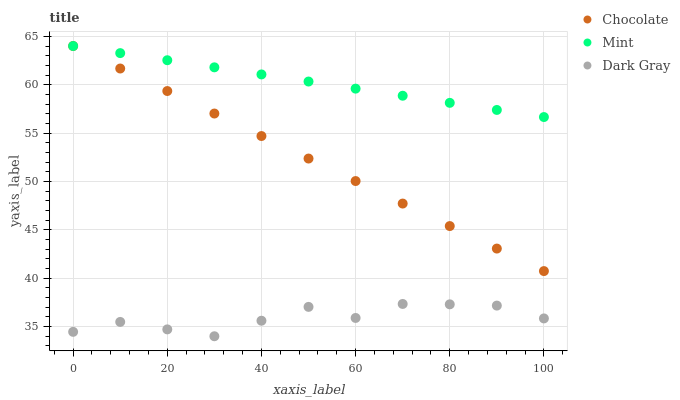Does Dark Gray have the minimum area under the curve?
Answer yes or no. Yes. Does Mint have the maximum area under the curve?
Answer yes or no. Yes. Does Chocolate have the minimum area under the curve?
Answer yes or no. No. Does Chocolate have the maximum area under the curve?
Answer yes or no. No. Is Chocolate the smoothest?
Answer yes or no. Yes. Is Dark Gray the roughest?
Answer yes or no. Yes. Is Mint the smoothest?
Answer yes or no. No. Is Mint the roughest?
Answer yes or no. No. Does Dark Gray have the lowest value?
Answer yes or no. Yes. Does Chocolate have the lowest value?
Answer yes or no. No. Does Chocolate have the highest value?
Answer yes or no. Yes. Is Dark Gray less than Mint?
Answer yes or no. Yes. Is Mint greater than Dark Gray?
Answer yes or no. Yes. Does Chocolate intersect Mint?
Answer yes or no. Yes. Is Chocolate less than Mint?
Answer yes or no. No. Is Chocolate greater than Mint?
Answer yes or no. No. Does Dark Gray intersect Mint?
Answer yes or no. No. 